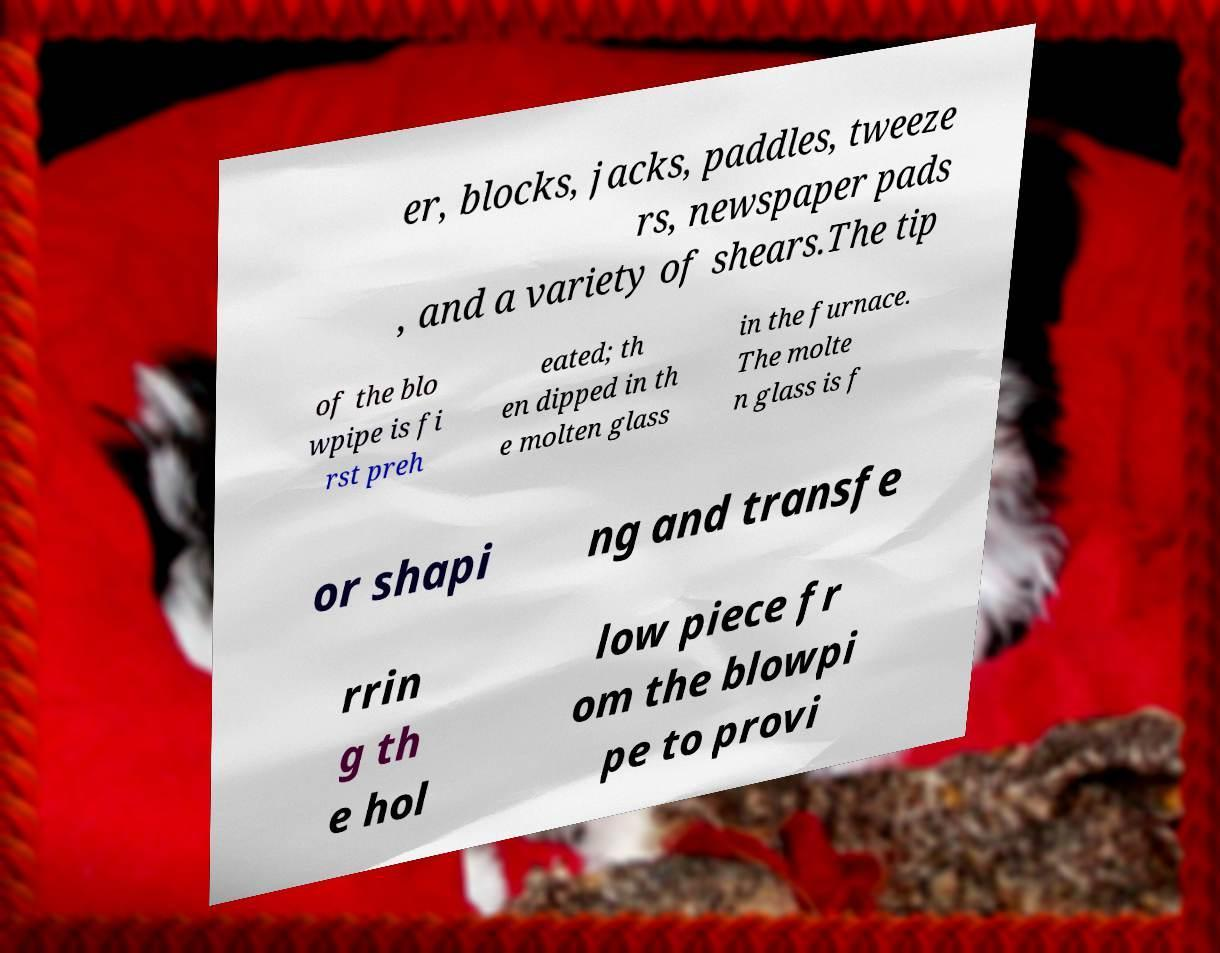I need the written content from this picture converted into text. Can you do that? er, blocks, jacks, paddles, tweeze rs, newspaper pads , and a variety of shears.The tip of the blo wpipe is fi rst preh eated; th en dipped in th e molten glass in the furnace. The molte n glass is f or shapi ng and transfe rrin g th e hol low piece fr om the blowpi pe to provi 